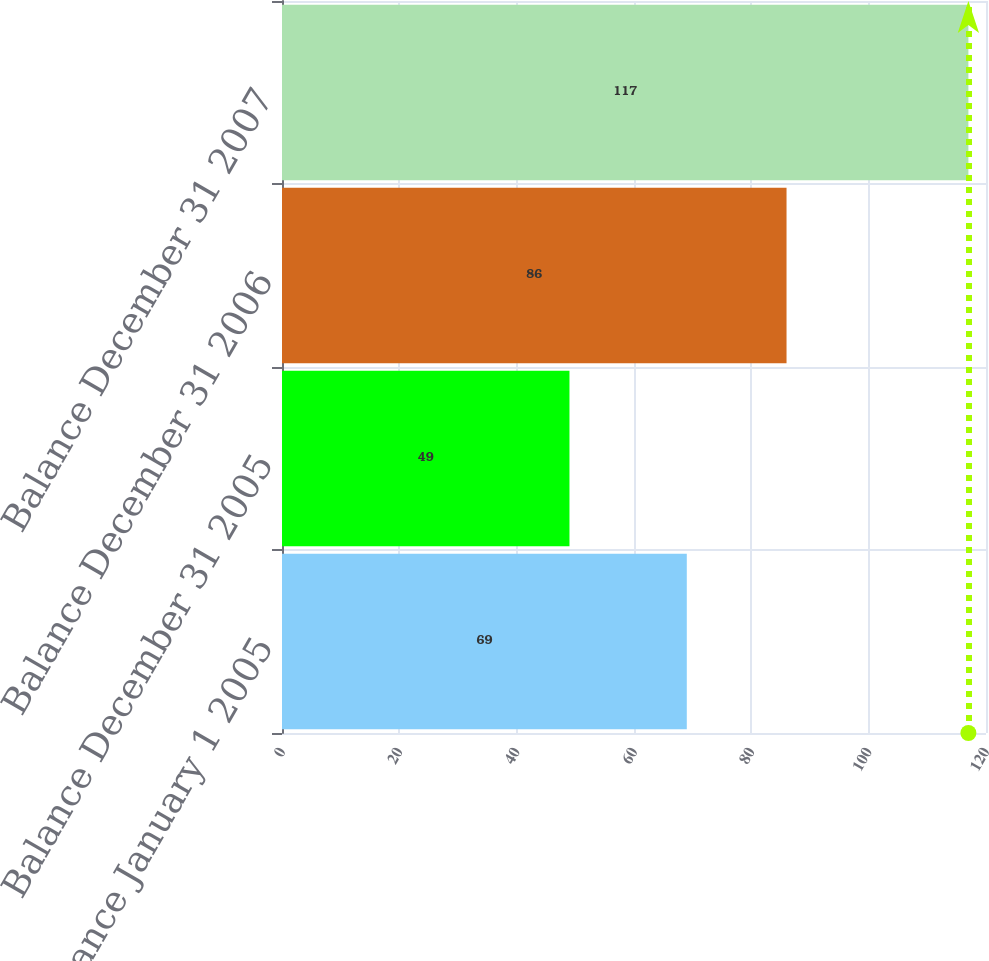Convert chart to OTSL. <chart><loc_0><loc_0><loc_500><loc_500><bar_chart><fcel>Balance January 1 2005<fcel>Balance December 31 2005<fcel>Balance December 31 2006<fcel>Balance December 31 2007<nl><fcel>69<fcel>49<fcel>86<fcel>117<nl></chart> 